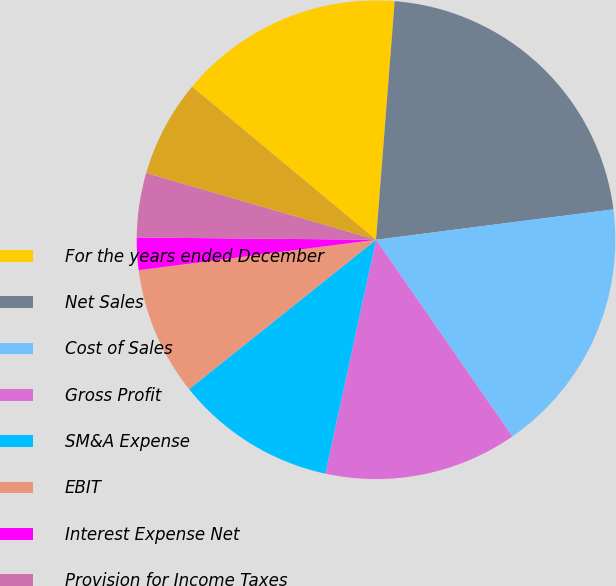Convert chart to OTSL. <chart><loc_0><loc_0><loc_500><loc_500><pie_chart><fcel>For the years ended December<fcel>Net Sales<fcel>Cost of Sales<fcel>Gross Profit<fcel>SM&A Expense<fcel>EBIT<fcel>Interest Expense Net<fcel>Provision for Income Taxes<fcel>Net Income<fcel>Net Income Per Share-Diluted<nl><fcel>15.21%<fcel>21.73%<fcel>17.38%<fcel>13.04%<fcel>10.87%<fcel>8.7%<fcel>2.18%<fcel>4.35%<fcel>6.52%<fcel>0.01%<nl></chart> 